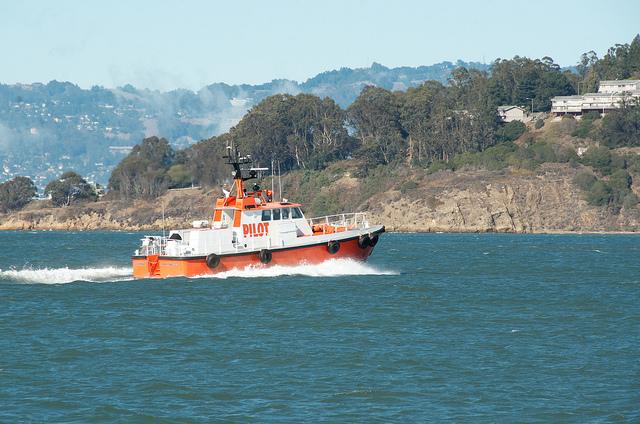The boat is what color?
Keep it brief. Orange and white. Is something on fire?
Be succinct. Yes. Do does the wording say on the boat?
Short answer required. Pilot. 